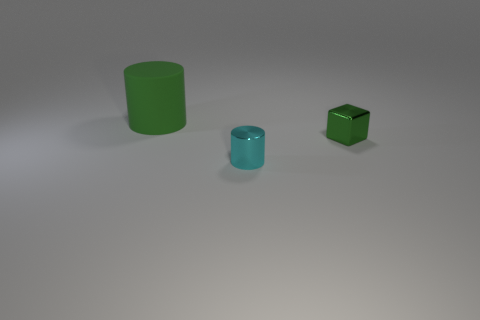Add 1 small purple shiny things. How many objects exist? 4 Subtract all cylinders. How many objects are left? 1 Add 1 big red metal cylinders. How many big red metal cylinders exist? 1 Subtract 1 green blocks. How many objects are left? 2 Subtract 1 cubes. How many cubes are left? 0 Subtract all purple cylinders. Subtract all cyan balls. How many cylinders are left? 2 Subtract all green blocks. How many cyan cylinders are left? 1 Subtract all green matte things. Subtract all green metal objects. How many objects are left? 1 Add 2 shiny objects. How many shiny objects are left? 4 